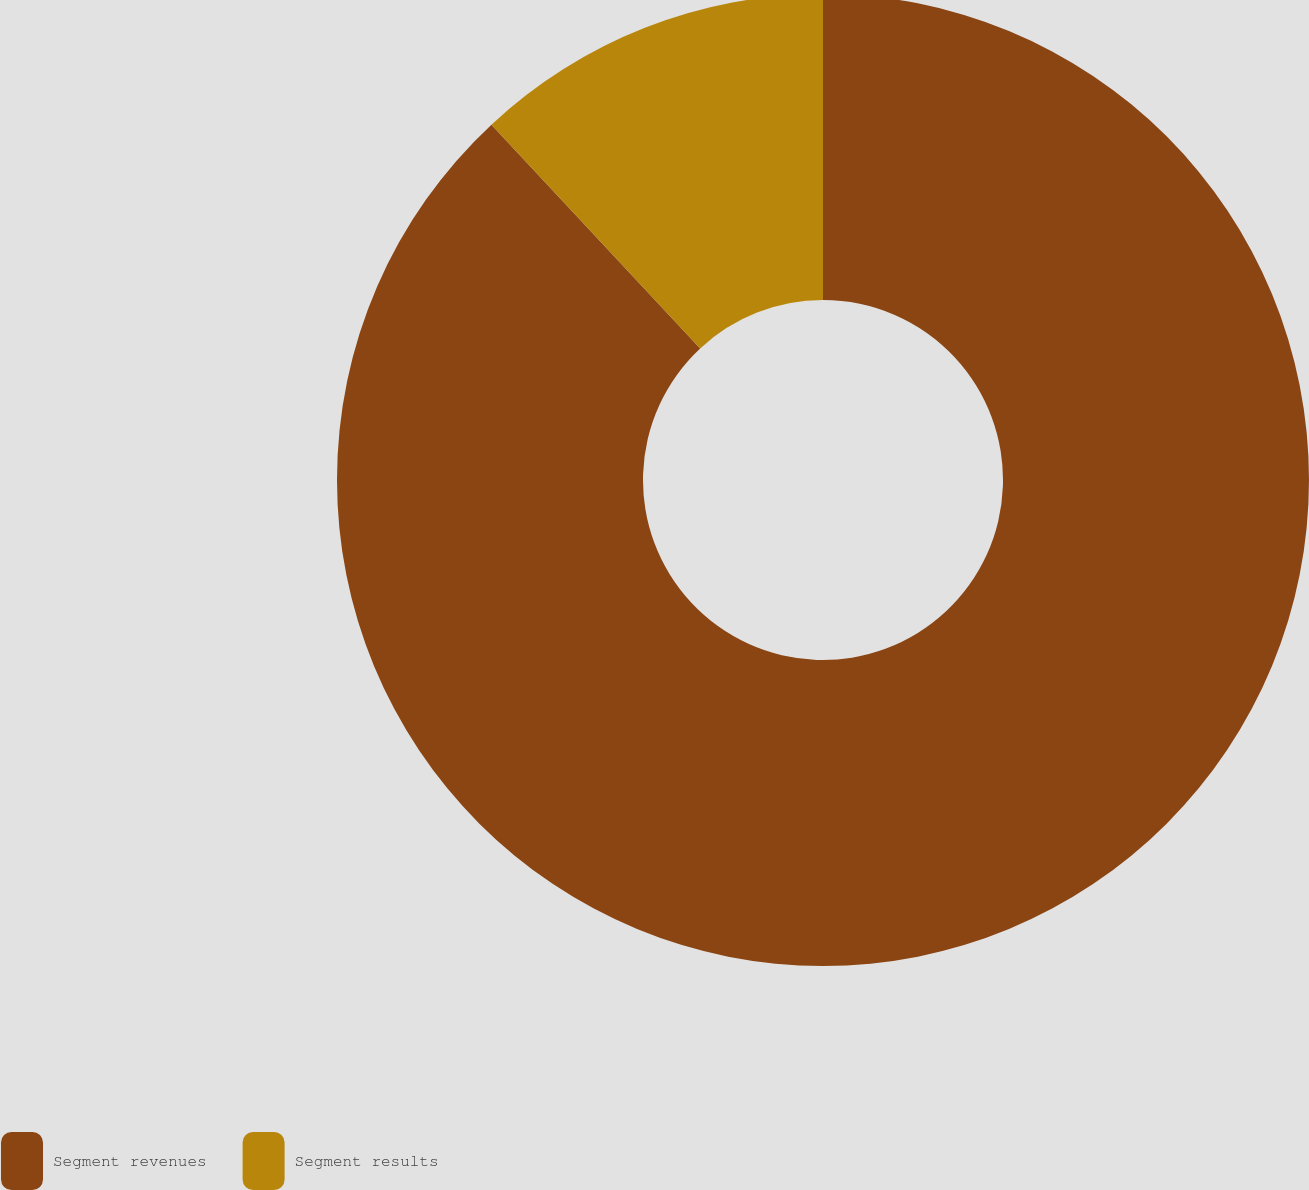Convert chart to OTSL. <chart><loc_0><loc_0><loc_500><loc_500><pie_chart><fcel>Segment revenues<fcel>Segment results<nl><fcel>88.05%<fcel>11.95%<nl></chart> 